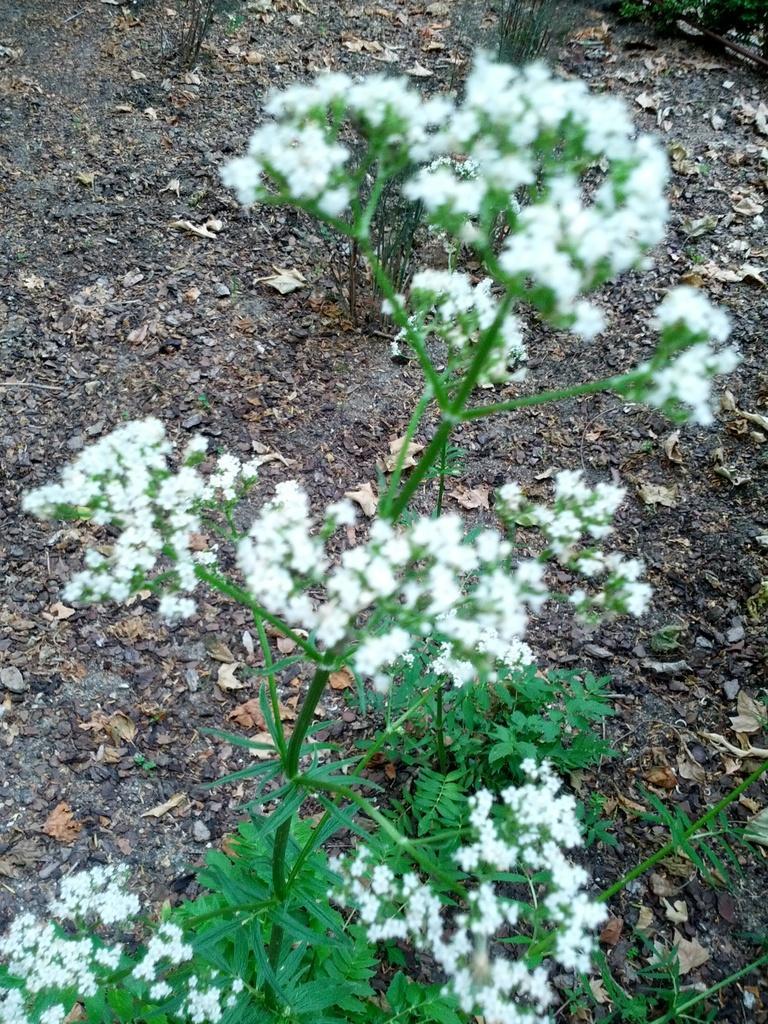In one or two sentences, can you explain what this image depicts? In the picture we can see a plant on it, we can see small white colorful flowers and under it we can see a mud surface with some dried leaves on it. 